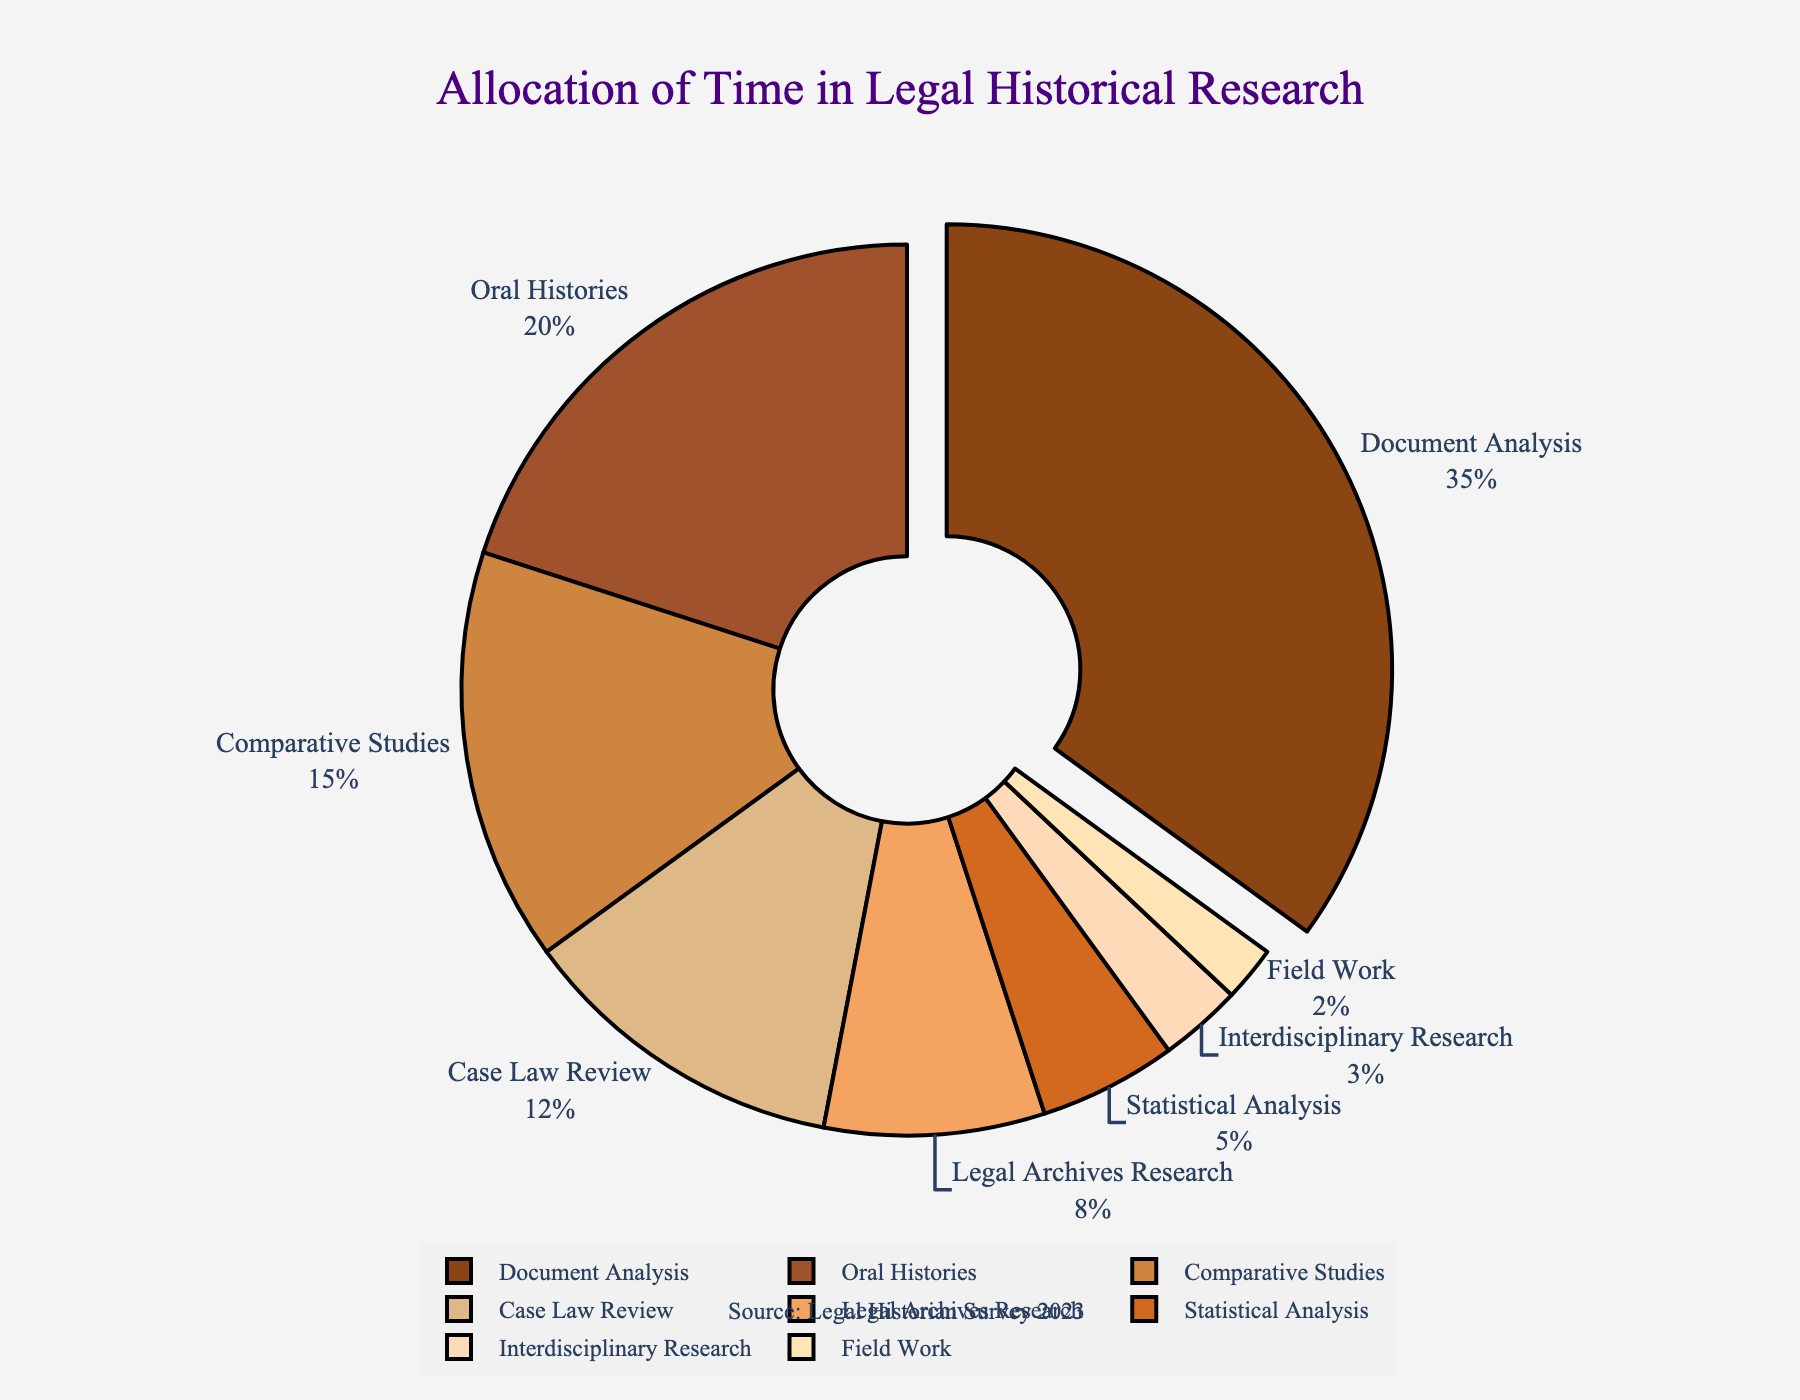What is the percentage of time spent on Document Analysis? The pie chart shows a segment labeled "Document Analysis" with its corresponding percentage.
Answer: 35% Which research method takes up the least amount of time? The pie chart shows that "Field Work" has the smallest segment when compared to other methods.
Answer: Field Work By how much does the time spent on Document Analysis exceed the time spent on Comparative Studies? The percentage of time spent on Document Analysis is 35% and on Comparative Studies is 15%. Subtract 15% from 35%. 35% - 15% = 20%.
Answer: 20% Compare the time allocation between Oral Histories and Case Law Review. From the chart, Oral Histories account for 20% and Case Law Review for 12%. Oral Histories have a higher percentage than Case Law Review.
Answer: Oral Histories > Case Law Review What proportion of time is dedicated to Legal Archives Research and Statistical Analysis together? Legal Archives Research is 8% and Statistical Analysis is 5%. Add these percentages together. 8% + 5% = 13%.
Answer: 13% What's the relative difference in time allocation between Legal Archives Research and Interdisciplinary Research? The percentage for Legal Archives Research is 8% and for Interdisciplinary Research, it is 3%. Subtract the smaller percentage from the larger one. 8% - 3% = 5%.
Answer: 5% How does the percentage of time spent on Interdisciplinary Research compare to Field Work? The pie chart shows that Interdisciplinary Research has a percentage of 3%, while Field Work has 2%. Interdisciplinary Research has a slightly higher percentage than Field Work.
Answer: Interdisciplinary Research > Field Work Which research method is highlighted or pulled out in the pie chart? The pie chart shows the segment for "Document Analysis" being pulled out slightly from the center, indicating it's the highlighted method.
Answer: Document Analysis 